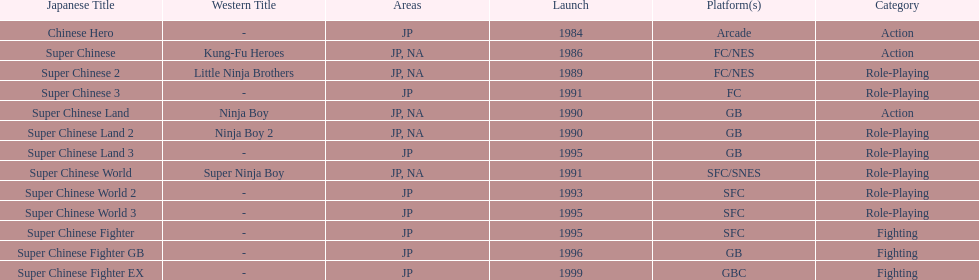Of the titles released in north america, which had the least releases? Super Chinese World. 